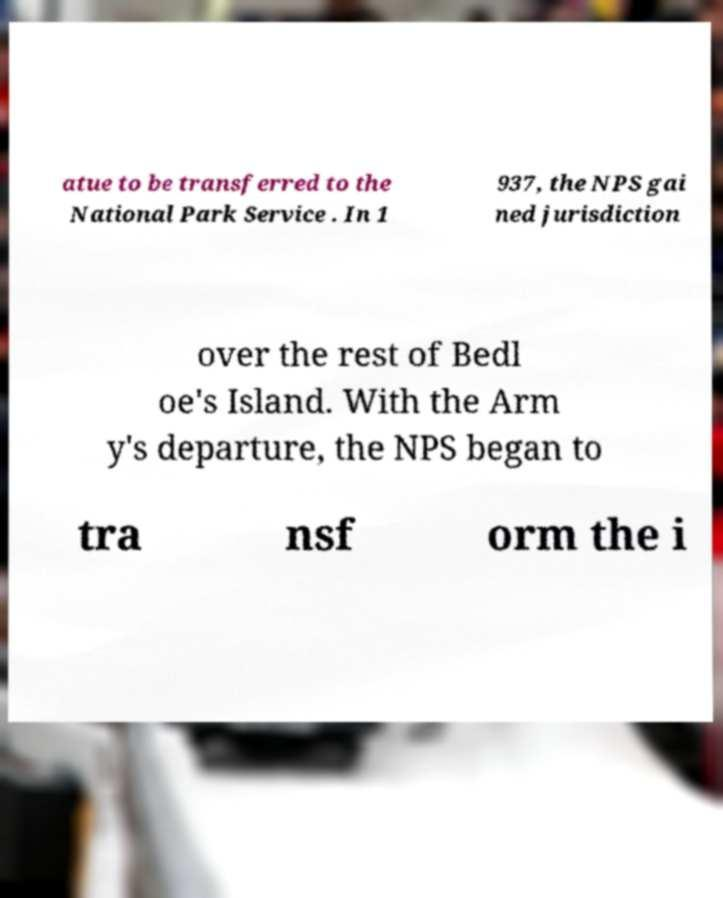Could you assist in decoding the text presented in this image and type it out clearly? atue to be transferred to the National Park Service . In 1 937, the NPS gai ned jurisdiction over the rest of Bedl oe's Island. With the Arm y's departure, the NPS began to tra nsf orm the i 